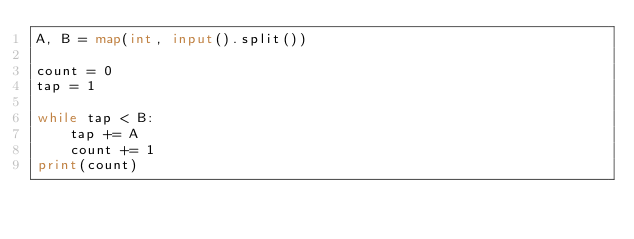<code> <loc_0><loc_0><loc_500><loc_500><_Python_>A, B = map(int, input().split())

count = 0
tap = 1

while tap < B:
    tap += A
    count += 1
print(count)</code> 